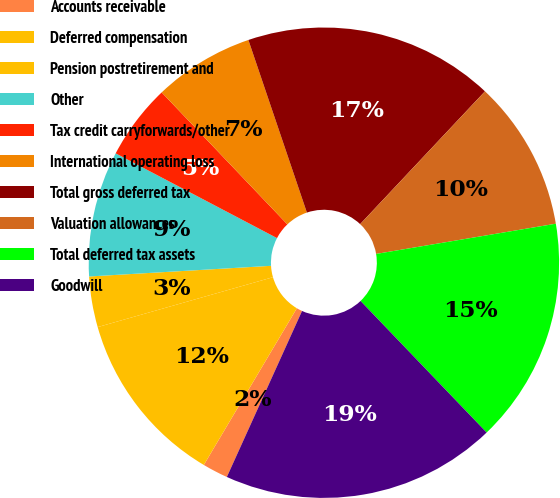Convert chart. <chart><loc_0><loc_0><loc_500><loc_500><pie_chart><fcel>Accounts receivable<fcel>Deferred compensation<fcel>Pension postretirement and<fcel>Other<fcel>Tax credit carryforwards/other<fcel>International operating loss<fcel>Total gross deferred tax<fcel>Valuation allowances<fcel>Total deferred tax assets<fcel>Goodwill<nl><fcel>1.76%<fcel>12.06%<fcel>3.48%<fcel>8.63%<fcel>5.19%<fcel>6.91%<fcel>17.21%<fcel>10.34%<fcel>15.49%<fcel>18.93%<nl></chart> 